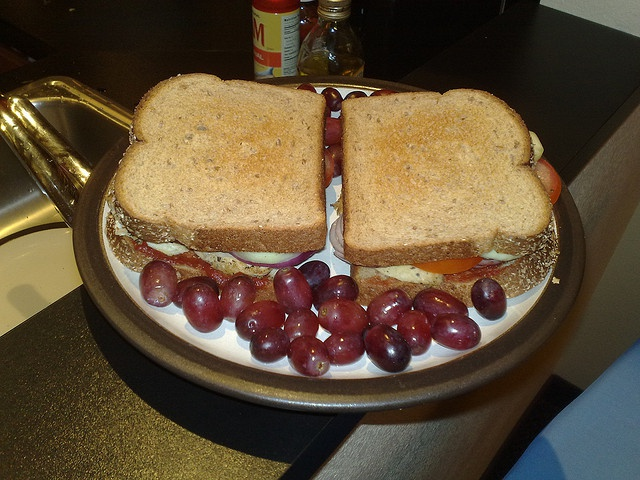Describe the objects in this image and their specific colors. I can see sandwich in black, tan, and olive tones, sandwich in black, tan, and olive tones, sink in black and olive tones, bottle in black, maroon, darkgreen, and gray tones, and bottle in black, maroon, gray, and navy tones in this image. 